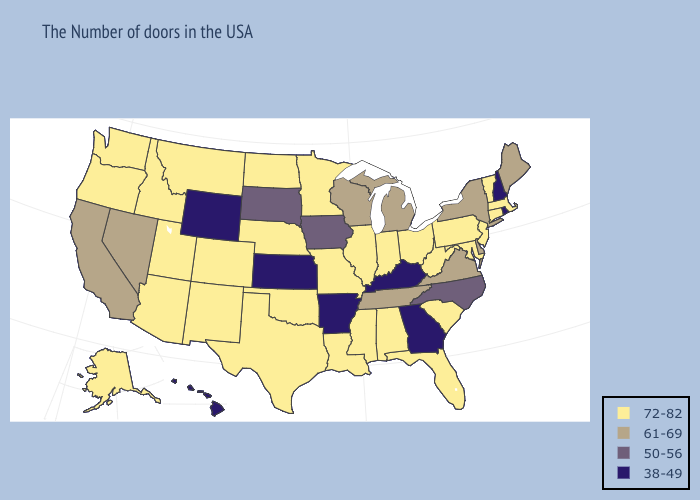What is the highest value in the South ?
Concise answer only. 72-82. Name the states that have a value in the range 72-82?
Short answer required. Massachusetts, Vermont, Connecticut, New Jersey, Maryland, Pennsylvania, South Carolina, West Virginia, Ohio, Florida, Indiana, Alabama, Illinois, Mississippi, Louisiana, Missouri, Minnesota, Nebraska, Oklahoma, Texas, North Dakota, Colorado, New Mexico, Utah, Montana, Arizona, Idaho, Washington, Oregon, Alaska. Does Iowa have the highest value in the USA?
Answer briefly. No. Does Utah have the highest value in the USA?
Give a very brief answer. Yes. What is the value of Oregon?
Give a very brief answer. 72-82. What is the highest value in the USA?
Quick response, please. 72-82. What is the value of Texas?
Short answer required. 72-82. Among the states that border Indiana , which have the highest value?
Short answer required. Ohio, Illinois. Is the legend a continuous bar?
Give a very brief answer. No. What is the value of Maryland?
Write a very short answer. 72-82. What is the lowest value in the USA?
Keep it brief. 38-49. Does Kansas have the lowest value in the MidWest?
Quick response, please. Yes. What is the value of Massachusetts?
Be succinct. 72-82. Name the states that have a value in the range 38-49?
Be succinct. Rhode Island, New Hampshire, Georgia, Kentucky, Arkansas, Kansas, Wyoming, Hawaii. 